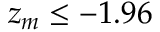Convert formula to latex. <formula><loc_0><loc_0><loc_500><loc_500>z _ { m } \leq - 1 . 9 6</formula> 